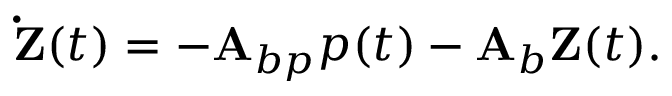Convert formula to latex. <formula><loc_0><loc_0><loc_500><loc_500>\dot { Z } ( t ) = - A _ { b p } p ( t ) - A _ { b } Z ( t ) .</formula> 